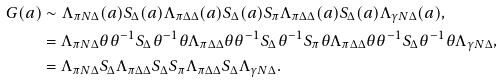<formula> <loc_0><loc_0><loc_500><loc_500>G ( a ) & \sim \Lambda _ { \pi N \Delta } ( a ) S _ { \Delta } ( a ) \Lambda _ { \pi \Delta \Delta } ( a ) S _ { \Delta } ( a ) S _ { \pi } \Lambda _ { \pi \Delta \Delta } ( a ) S _ { \Delta } ( a ) \Lambda _ { \gamma N \Delta } ( a ) , \\ & = \Lambda _ { \pi N \Delta } \theta \theta ^ { - 1 } S _ { \Delta } \theta ^ { - 1 } \theta \Lambda _ { \pi \Delta \Delta } \theta \theta ^ { - 1 } S _ { \Delta } \theta ^ { - 1 } S _ { \pi } \theta \Lambda _ { \pi \Delta \Delta } \theta \theta ^ { - 1 } S _ { \Delta } \theta ^ { - 1 } \theta \Lambda _ { \gamma N \Delta } , \\ & = \Lambda _ { \pi N \Delta } S _ { \Delta } \Lambda _ { \pi \Delta \Delta } S _ { \Delta } S _ { \pi } \Lambda _ { \pi \Delta \Delta } S _ { \Delta } \Lambda _ { \gamma N \Delta } .</formula> 